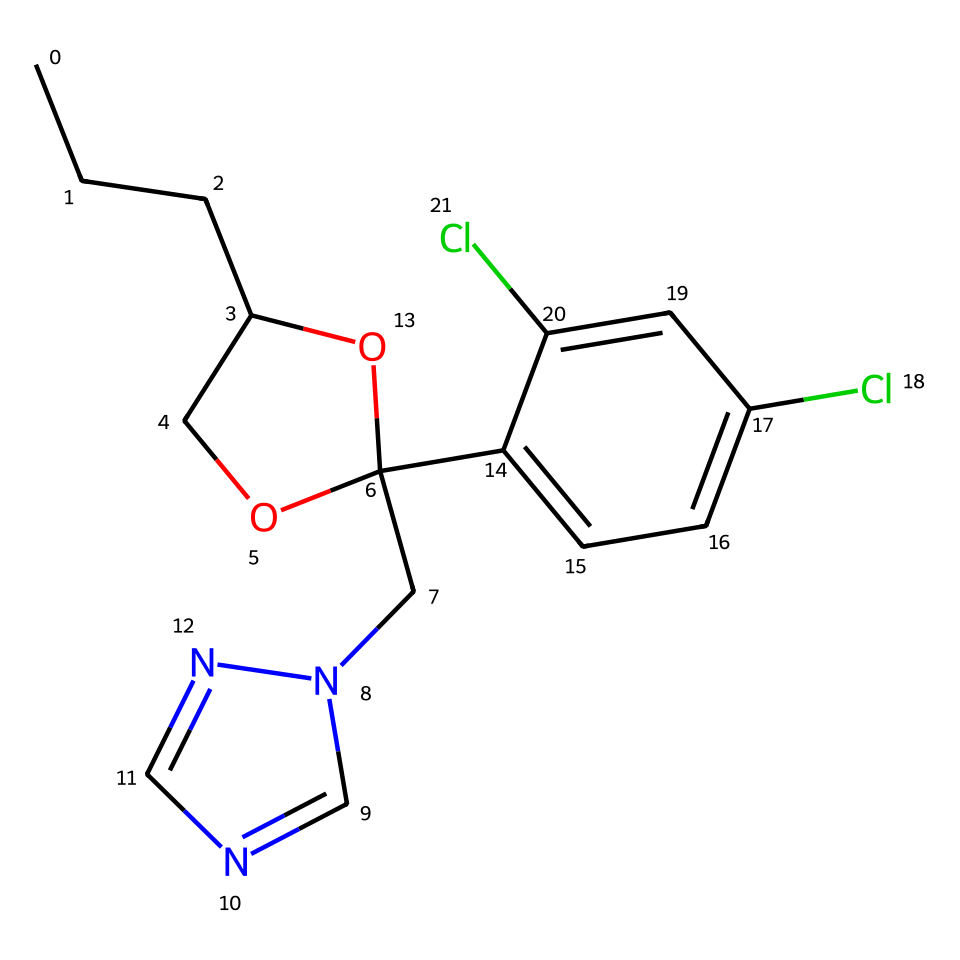What is the total number of carbon atoms in this chemical? By inspecting the structure, I count all the carbon (C) atoms present. In the given SMILES, I can identify a total of ten carbon atoms throughout the entire structure.
Answer: ten What functional group is present in this compound? The structure shows a hydroxyl (-OH) group, indicated by the presence of oxygen (O) bonded with hydrogen. This suggests that propiconazole contains a hydroxyl functional group.
Answer: hydroxyl How many chlorine atoms are there in this chemical? By looking at the SMILES representation, I notice two chlorine (Cl) atoms connected to the aromatic ring in the molecule.
Answer: two Which part of this chemical structure enhances its effectiveness as a fungicide? The nitrogen atoms and the multiple aromatic rings within the structure contribute to its biological activity, enhancing its capability to interfere with fungal metabolism. These features are critical for a fungicide's function.
Answer: nitrogen atoms and aromatic rings Does this compound belong to a specific class of fungicides? Yes, propiconazole is classified as a triazole fungicide due to the presence of the triazole ring in its structure, which is characteristic of this group of chemicals.
Answer: triazole What is the molecular weight of this compound? To determine the molecular weight, I would have to calculate the sum of the atomic weights of all the atoms present in this compound based on its chemical formula derived from the SMILES. The result leads to a molecular weight of approximately 341.2 g/mol.
Answer: 341.2 Is this compound likely to have low or high solubility in water? Based on the chemical structure, the presence of multiple aromatic rings and a low number of polar functional groups suggests that it would have low solubility in water. Thus, this compound is likely to be hydrophobic.
Answer: low 